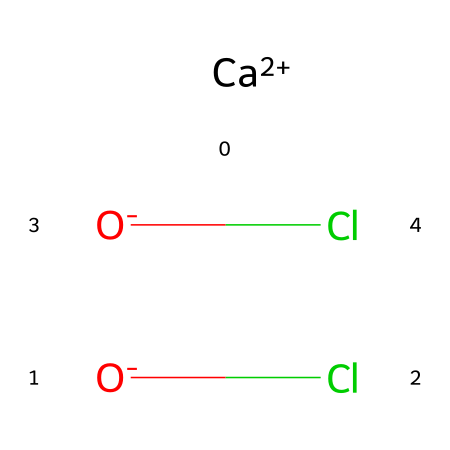What is the chemical name of the compound represented by the SMILES? The SMILES notation represents calcium hypochlorite, which consists of calcium and hypochlorite ions.
Answer: calcium hypochlorite How many oxygen atoms are present in this molecule? By analyzing the SMILES, we see there are two O atoms in the hypochlorite ions.
Answer: 2 What is the oxidation state of calcium in this chemical? Calcium typically has an oxidation state of +2, noted as [Ca+2] in the SMILES representation.
Answer: +2 How many chlorine atoms are in calcium hypochlorite? The structure includes two hypochlorite ions, each containing one chlorine atom, leading to a total of two Cl atoms.
Answer: 2 Is calcium hypochlorite an oxidizer? Yes, due to its chemical structure, which includes chlorine in a +1 oxidation state, it acts as a strong oxidizing agent.
Answer: Yes What type of ions does calcium hypochlorite consist of? It consists of calcium ions and hypochlorite ions, where the hypochlorite ions are responsible for its disinfectant properties.
Answer: Calcium and hypochlorite ions 